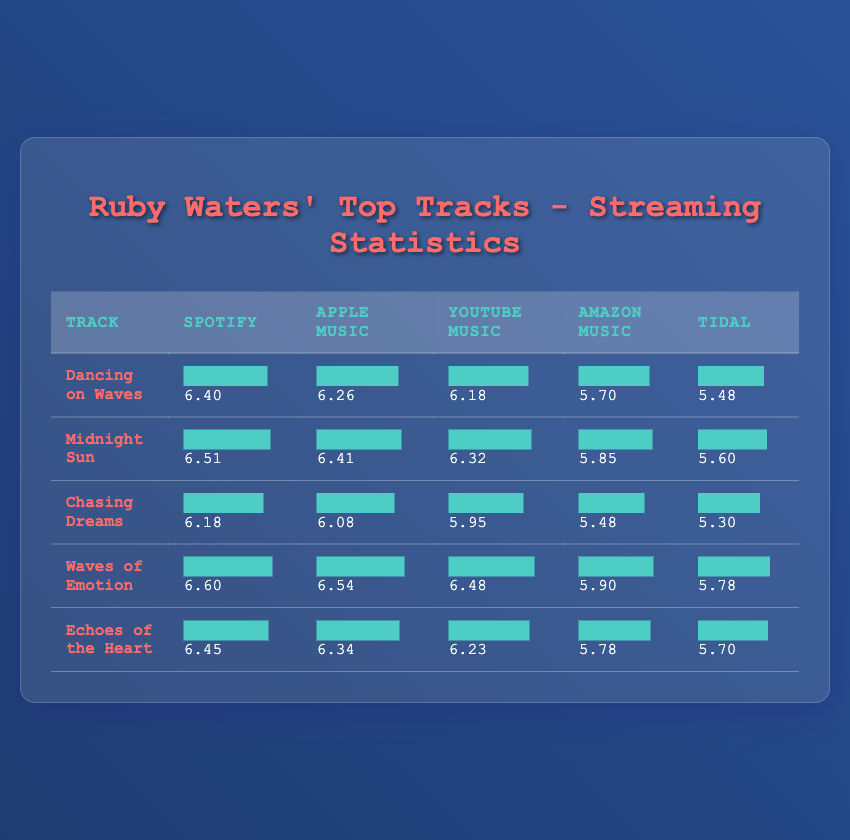What is the highest logarithmic value for Spotify among Ruby Waters' tracks? The highest value for Spotify is found in the "Waves of Emotion" track, which has a logarithmic value of 6.60.
Answer: 6.60 Which track has the lowest streaming statistics on Amazon Music? By checking the values in the table, "Chasing Dreams" has the lowest value on Amazon Music, with a logarithmic value of 5.48.
Answer: 5.48 What are the combined logarithmic values of "Echoes of the Heart" and "Dancing on Waves" for YouTube Music? The logarithmic values are 6.23 for "Echoes of the Heart" and 6.18 for "Dancing on Waves." Their combined total is 6.23 + 6.18 = 12.41.
Answer: 12.41 Is "Midnight Sun" the most streamed track on Apple Music? No, according to the table, "Waves of Emotion" has a higher logarithmic value of 6.54 compared to "Midnight Sun" at 6.41.
Answer: No What is the average logarithmic value for Ruby Waters' tracks on Spotify? The logarithmic values on Spotify are 6.40, 6.51, 6.18, 6.60, and 6.45. Their sum is 31.14, and dividing by 5 gives an average of 31.14 / 5 = 6.228.
Answer: 6.228 